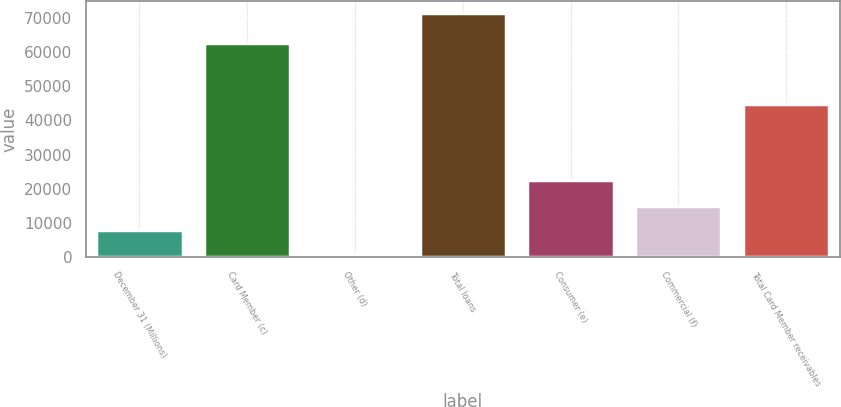Convert chart. <chart><loc_0><loc_0><loc_500><loc_500><bar_chart><fcel>December 31 (Millions)<fcel>Card Member (c)<fcel>Other (d)<fcel>Total loans<fcel>Consumer (e)<fcel>Commercial (f)<fcel>Total Card Member receivables<nl><fcel>7785.1<fcel>62592<fcel>726<fcel>71317<fcel>22468<fcel>14844.2<fcel>44851<nl></chart> 